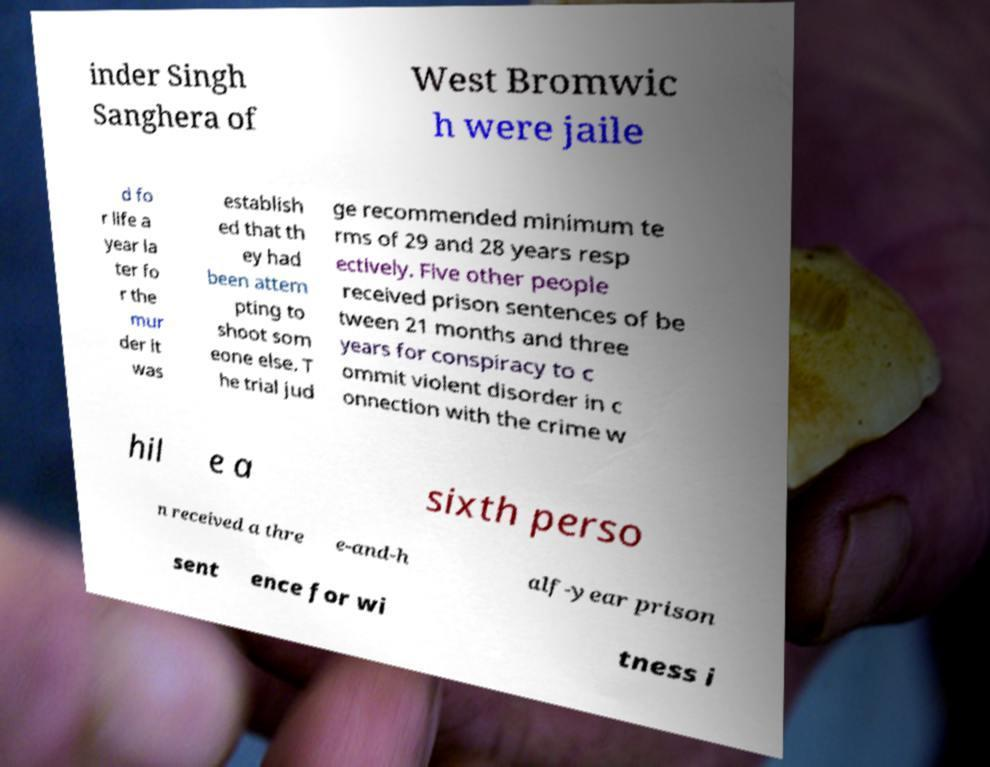I need the written content from this picture converted into text. Can you do that? inder Singh Sanghera of West Bromwic h were jaile d fo r life a year la ter fo r the mur der it was establish ed that th ey had been attem pting to shoot som eone else. T he trial jud ge recommended minimum te rms of 29 and 28 years resp ectively. Five other people received prison sentences of be tween 21 months and three years for conspiracy to c ommit violent disorder in c onnection with the crime w hil e a sixth perso n received a thre e-and-h alf-year prison sent ence for wi tness i 